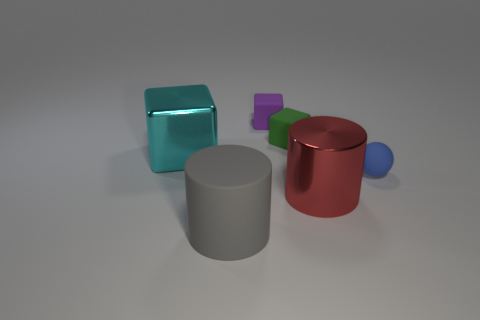Add 1 rubber objects. How many objects exist? 7 Subtract all cylinders. How many objects are left? 4 Add 3 tiny blue spheres. How many tiny blue spheres exist? 4 Subtract 1 blue spheres. How many objects are left? 5 Subtract all small rubber blocks. Subtract all green objects. How many objects are left? 3 Add 1 small purple matte things. How many small purple matte things are left? 2 